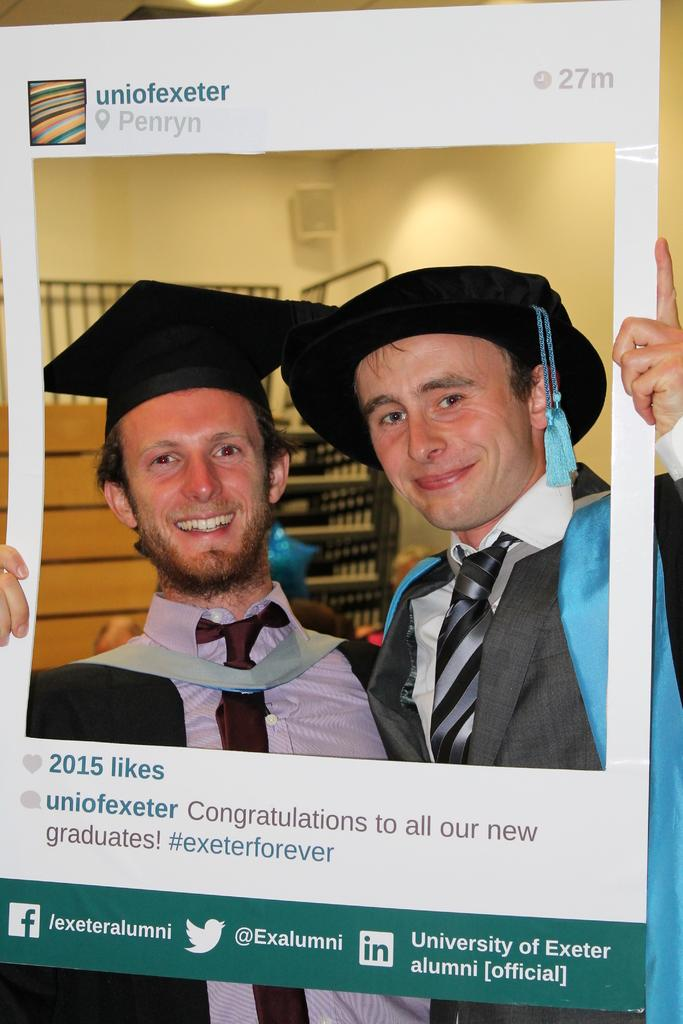How many people are in the image? There are two men in the image. What are the men wearing on their heads? The men are wearing caps. What are the men holding in the image? The men are holding a placard. What can be seen in the background of the image? There are racks visible in the background of the image. What grade did the men receive for their performance in the image? There is no indication of a performance or grade in the image; it simply shows two men holding a placard. How much did the men rate the service in the image? There is no indication of a service or rating in the image; it simply shows two men holding a placard. 